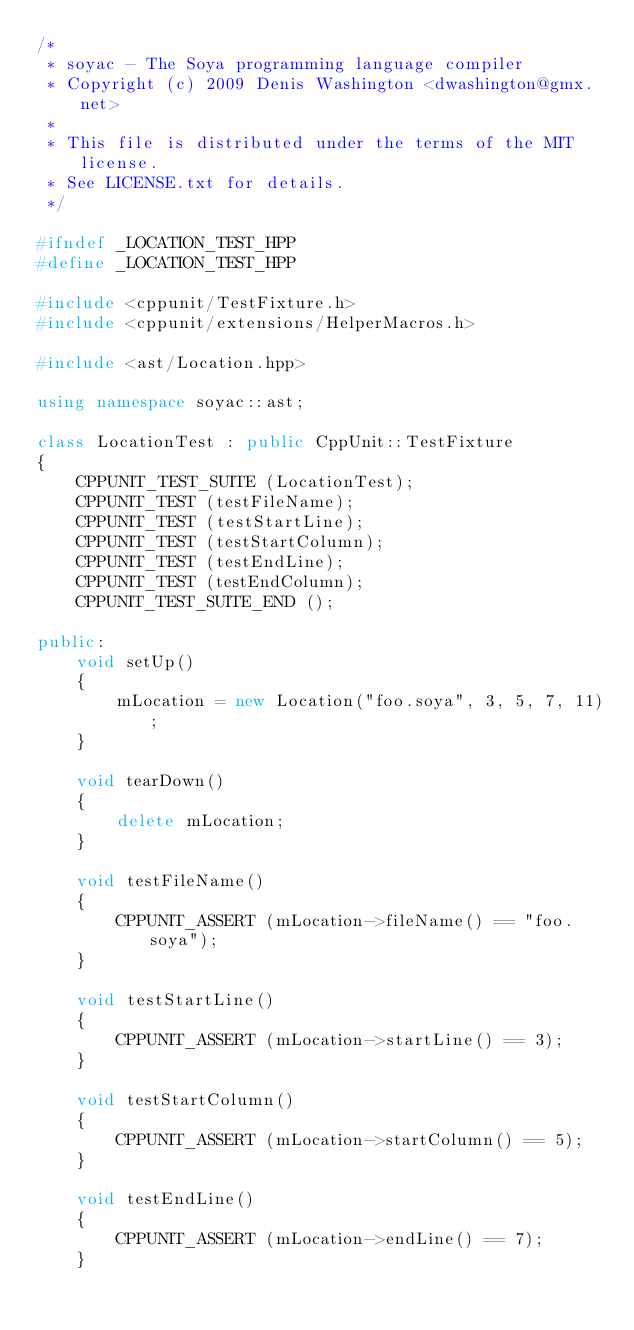<code> <loc_0><loc_0><loc_500><loc_500><_C++_>/*
 * soyac - The Soya programming language compiler
 * Copyright (c) 2009 Denis Washington <dwashington@gmx.net>
 *
 * This file is distributed under the terms of the MIT license.
 * See LICENSE.txt for details.
 */

#ifndef _LOCATION_TEST_HPP
#define _LOCATION_TEST_HPP

#include <cppunit/TestFixture.h>
#include <cppunit/extensions/HelperMacros.h>

#include <ast/Location.hpp>

using namespace soyac::ast;

class LocationTest : public CppUnit::TestFixture
{
    CPPUNIT_TEST_SUITE (LocationTest);
    CPPUNIT_TEST (testFileName);
    CPPUNIT_TEST (testStartLine);
    CPPUNIT_TEST (testStartColumn);
    CPPUNIT_TEST (testEndLine);
    CPPUNIT_TEST (testEndColumn);
    CPPUNIT_TEST_SUITE_END ();

public:
    void setUp()
    {
        mLocation = new Location("foo.soya", 3, 5, 7, 11);
    }

    void tearDown()
    {
        delete mLocation;
    }

    void testFileName()
    {
        CPPUNIT_ASSERT (mLocation->fileName() == "foo.soya");
    }

    void testStartLine()
    {
        CPPUNIT_ASSERT (mLocation->startLine() == 3);
    }

    void testStartColumn()
    {
        CPPUNIT_ASSERT (mLocation->startColumn() == 5);
    }

    void testEndLine()
    {
        CPPUNIT_ASSERT (mLocation->endLine() == 7);
    }
</code> 